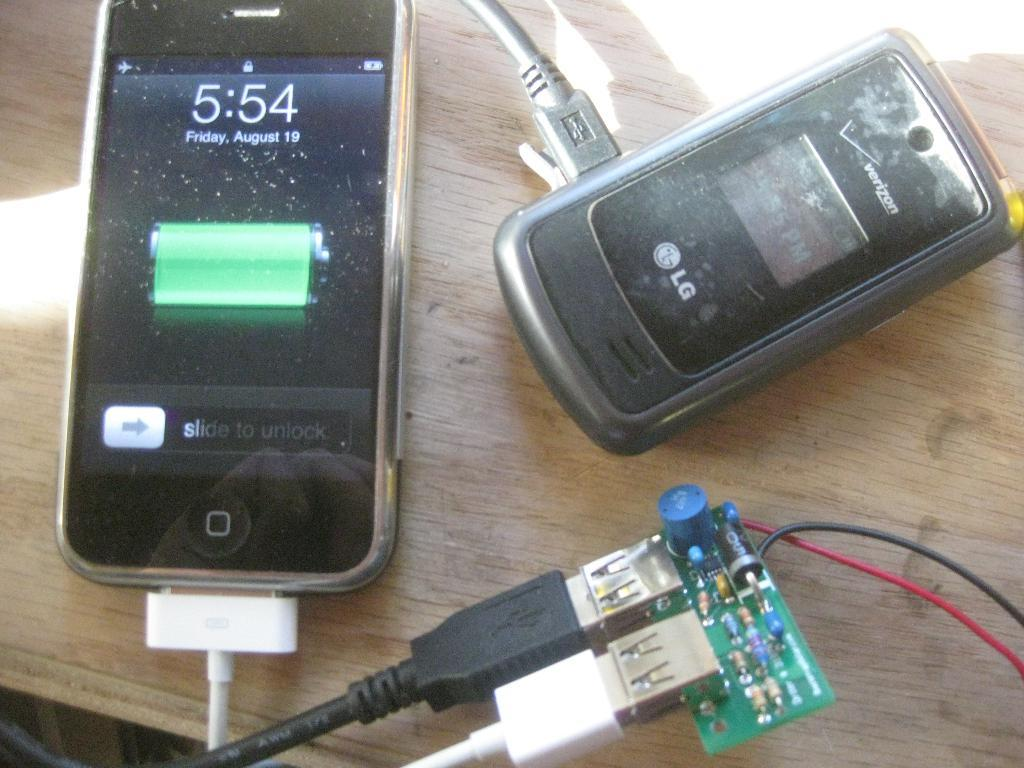Provide a one-sentence caption for the provided image. Two cell phones charging and one has 5:54 written on the face. 